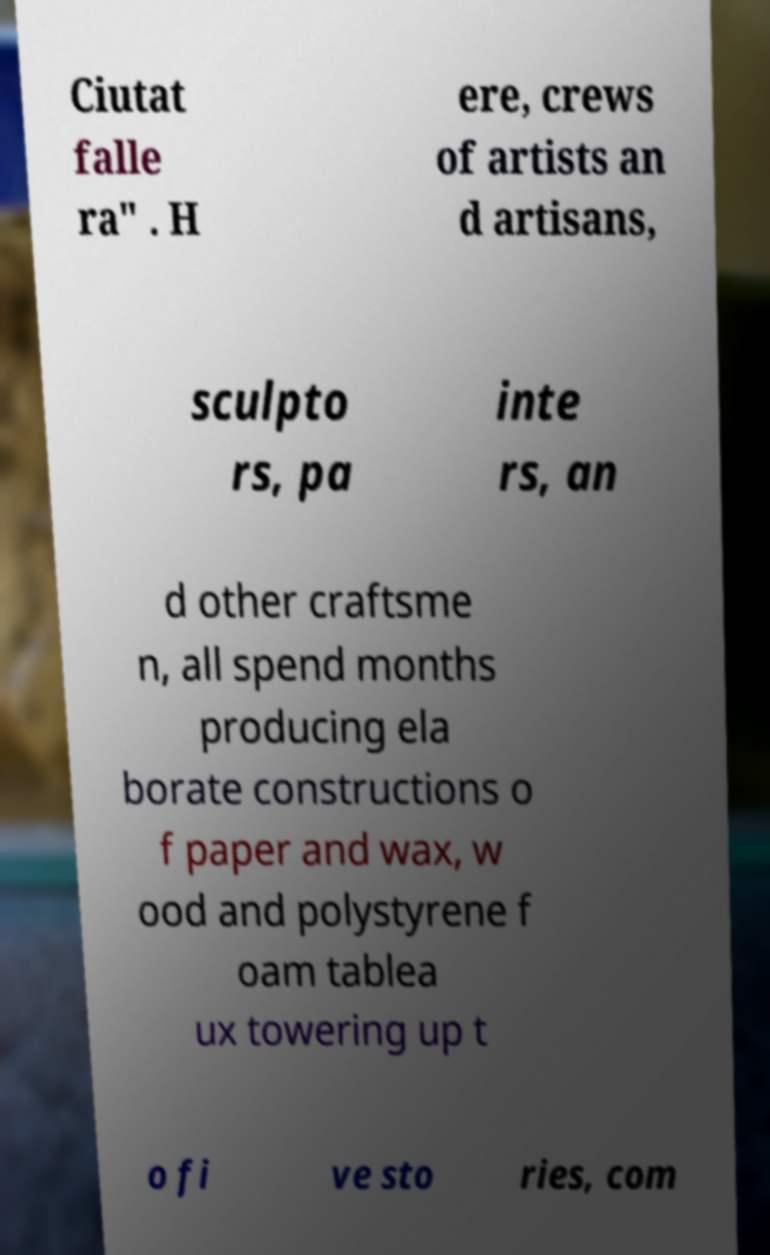Can you read and provide the text displayed in the image?This photo seems to have some interesting text. Can you extract and type it out for me? Ciutat falle ra" . H ere, crews of artists an d artisans, sculpto rs, pa inte rs, an d other craftsme n, all spend months producing ela borate constructions o f paper and wax, w ood and polystyrene f oam tablea ux towering up t o fi ve sto ries, com 